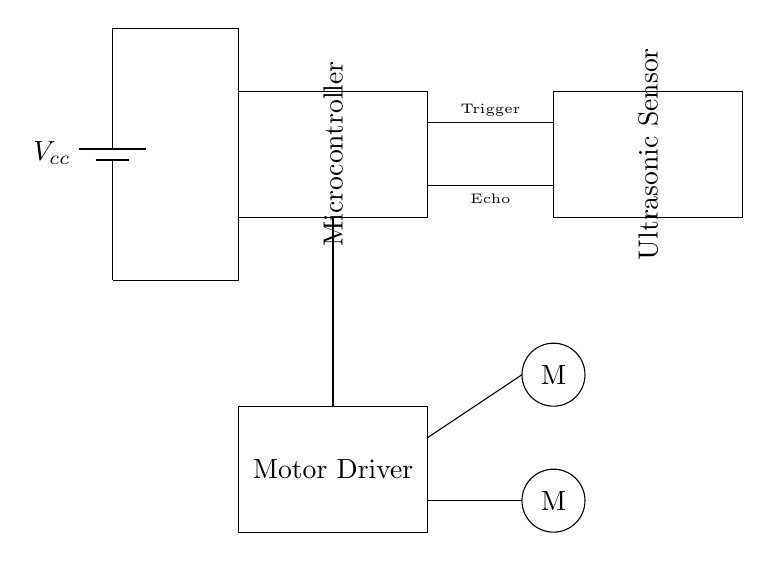What is the power supply voltage in this circuit? In the circuit diagram, the power supply component labeled as Vcc at the battery indicates a voltage, but it doesn't specify a value in the diagram itself. Typically, in similar circuits, a common value is five volts.
Answer: five volts What are the two main components of this circuit? The circuit diagram prominently features a microcontroller and an ultrasonic sensor as its primary components. These components are represented as rectangles with their names labeled inside them.
Answer: microcontroller and ultrasonic sensor How many motors are connected to the motor driver? The motor driver is connected to two motors shown as circles in the diagram. Each motor is labeled as "M," indicating that there are two motors in total.
Answer: two motors What is the function of the ultrasonic sensor in this circuit? The ultrasonic sensor's primary function is to measure distance; it has two ports labeled Trigger and Echo, which are used to send and receive ultrasonic waves, facilitating distance measurement for obstacle detection.
Answer: measure distance Which component connects the microcontroller to the motor driver? A single wire connects the microcontroller to the motor driver, indicated by the vertical line extending from the microcontroller to the motor driver's section. This connection allows the microcontroller to control the motor driver's operation.
Answer: wire 